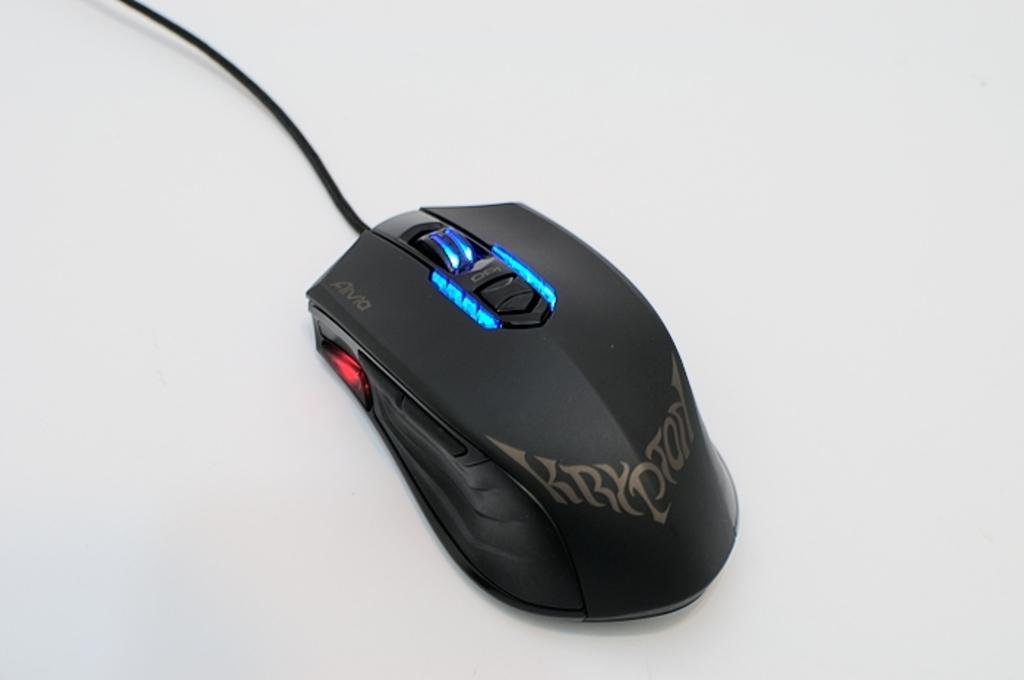<image>
Give a short and clear explanation of the subsequent image. a black krypton gaming mouse with blue lighting by its wheel. 